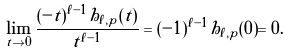Convert formula to latex. <formula><loc_0><loc_0><loc_500><loc_500>\lim _ { t \to 0 } \frac { ( - t ) ^ { \ell - 1 } h _ { \ell , p } ( t ) } { t ^ { \ell - 1 } } = ( - 1 ) ^ { \ell - 1 } h _ { \ell , p } ( 0 ) = 0 .</formula> 